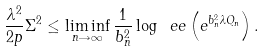Convert formula to latex. <formula><loc_0><loc_0><loc_500><loc_500>\frac { \lambda ^ { 2 } } { 2 p } \Sigma ^ { 2 } \leq \liminf _ { n \rightarrow \infty } \frac { 1 } { b _ { n } ^ { 2 } } \log \ e e \left ( e ^ { b _ { n } ^ { 2 } \lambda Q _ { n } } \right ) .</formula> 